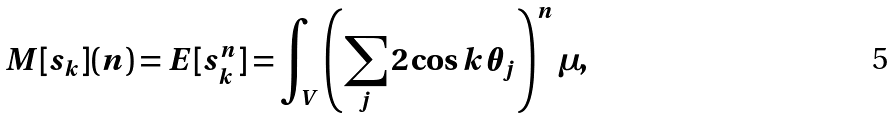Convert formula to latex. <formula><loc_0><loc_0><loc_500><loc_500>M [ s _ { k } ] ( n ) = E [ s _ { k } ^ { n } ] = \int _ { V } \left ( \sum _ { j } 2 \cos k \theta _ { j } \right ) ^ { n } \mu ,</formula> 